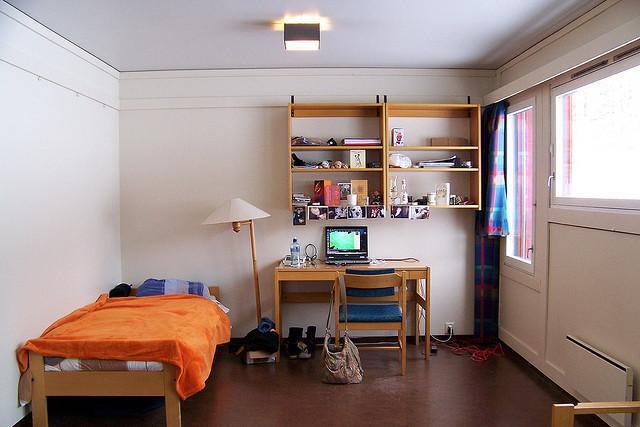How many lights are there?
Give a very brief answer. 2. How many handbags are there?
Give a very brief answer. 1. 